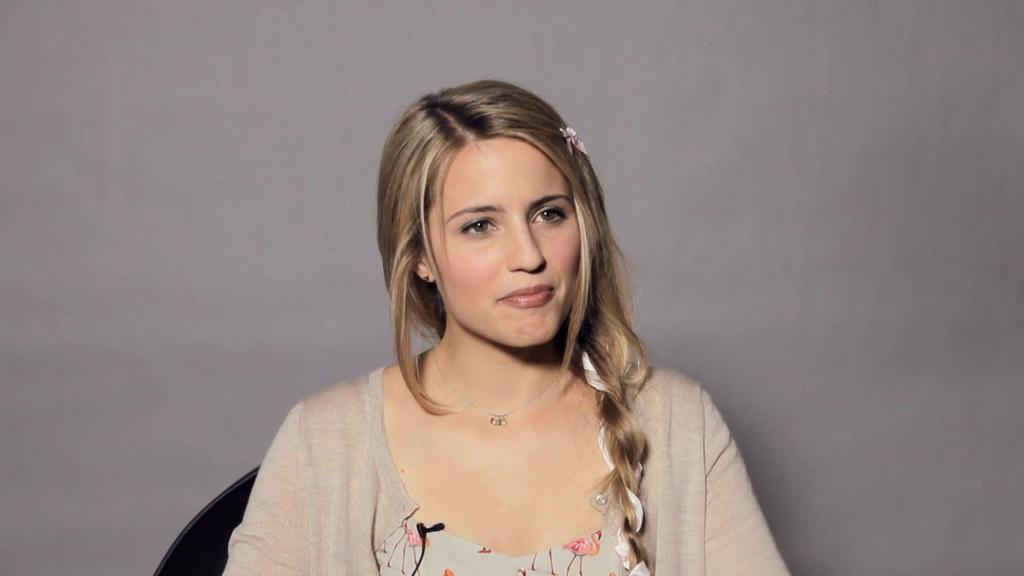Who is present in the image? There is a woman in the image. What is the woman's facial expression? The woman has a smiling face. Can you describe the background of the image? The background of the image is light in color. What type of crime is being committed in the image? There is no crime being committed in the image; it features a woman with a smiling face against a light-colored background. Can you see any snakes in the image? There are no snakes present in the image. 